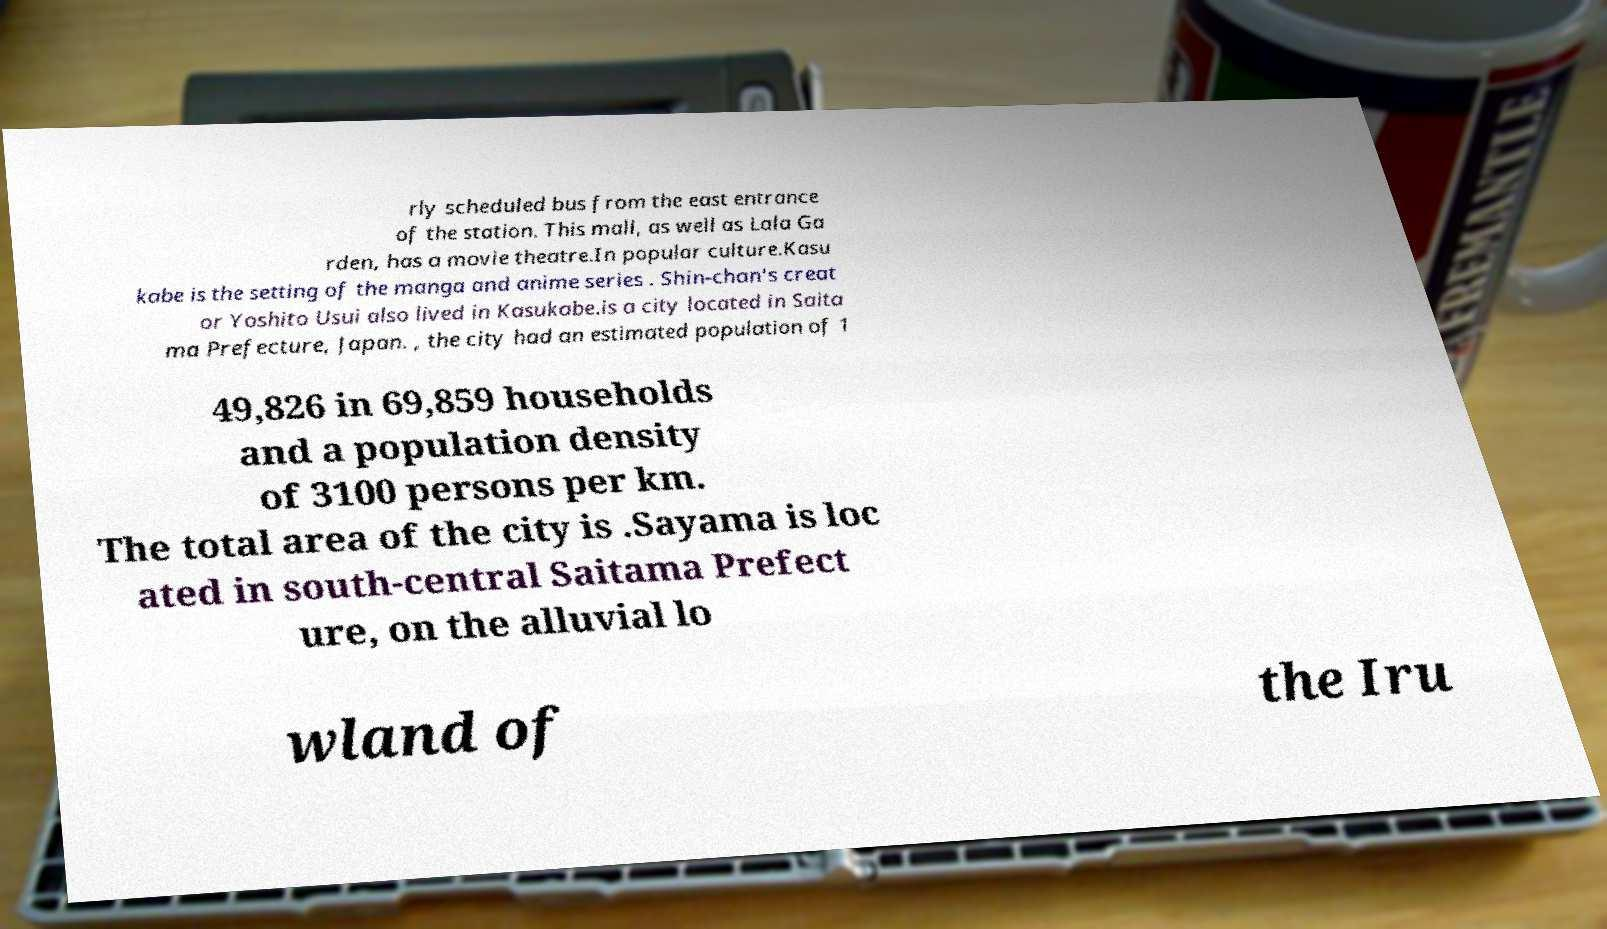Please read and relay the text visible in this image. What does it say? rly scheduled bus from the east entrance of the station. This mall, as well as Lala Ga rden, has a movie theatre.In popular culture.Kasu kabe is the setting of the manga and anime series . Shin-chan's creat or Yoshito Usui also lived in Kasukabe.is a city located in Saita ma Prefecture, Japan. , the city had an estimated population of 1 49,826 in 69,859 households and a population density of 3100 persons per km. The total area of the city is .Sayama is loc ated in south-central Saitama Prefect ure, on the alluvial lo wland of the Iru 